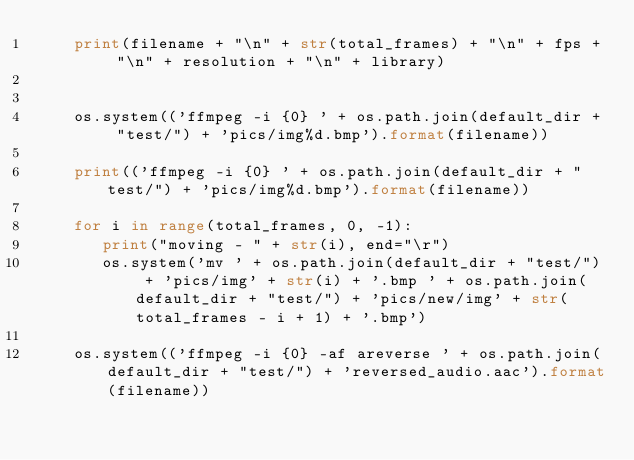Convert code to text. <code><loc_0><loc_0><loc_500><loc_500><_Python_>    print(filename + "\n" + str(total_frames) + "\n" + fps + "\n" + resolution + "\n" + library)


    os.system(('ffmpeg -i {0} ' + os.path.join(default_dir + "test/") + 'pics/img%d.bmp').format(filename))

    print(('ffmpeg -i {0} ' + os.path.join(default_dir + "test/") + 'pics/img%d.bmp').format(filename))

    for i in range(total_frames, 0, -1):
       print("moving - " + str(i), end="\r")
       os.system('mv ' + os.path.join(default_dir + "test/") + 'pics/img' + str(i) + '.bmp ' + os.path.join(default_dir + "test/") + 'pics/new/img' + str(total_frames - i + 1) + '.bmp')

    os.system(('ffmpeg -i {0} -af areverse ' + os.path.join(default_dir + "test/") + 'reversed_audio.aac').format(filename))</code> 